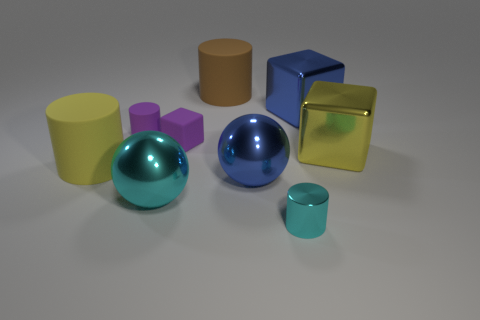There is a thing that is the same color as the tiny rubber cylinder; what size is it?
Offer a terse response. Small. What is the tiny cube made of?
Provide a succinct answer. Rubber. There is a cyan cylinder; what number of big metal balls are right of it?
Offer a very short reply. 0. Do the tiny block and the small metal cylinder have the same color?
Your answer should be compact. No. What number of rubber objects are the same color as the small rubber block?
Offer a terse response. 1. Are there more purple objects than rubber blocks?
Make the answer very short. Yes. What is the size of the cylinder that is both left of the large blue sphere and to the right of the large cyan thing?
Provide a short and direct response. Large. Is the material of the big cylinder that is in front of the purple cylinder the same as the large blue object that is to the left of the big blue block?
Provide a succinct answer. No. What is the shape of the brown thing that is the same size as the yellow rubber thing?
Provide a short and direct response. Cylinder. Are there fewer shiny cubes than cyan spheres?
Ensure brevity in your answer.  No. 